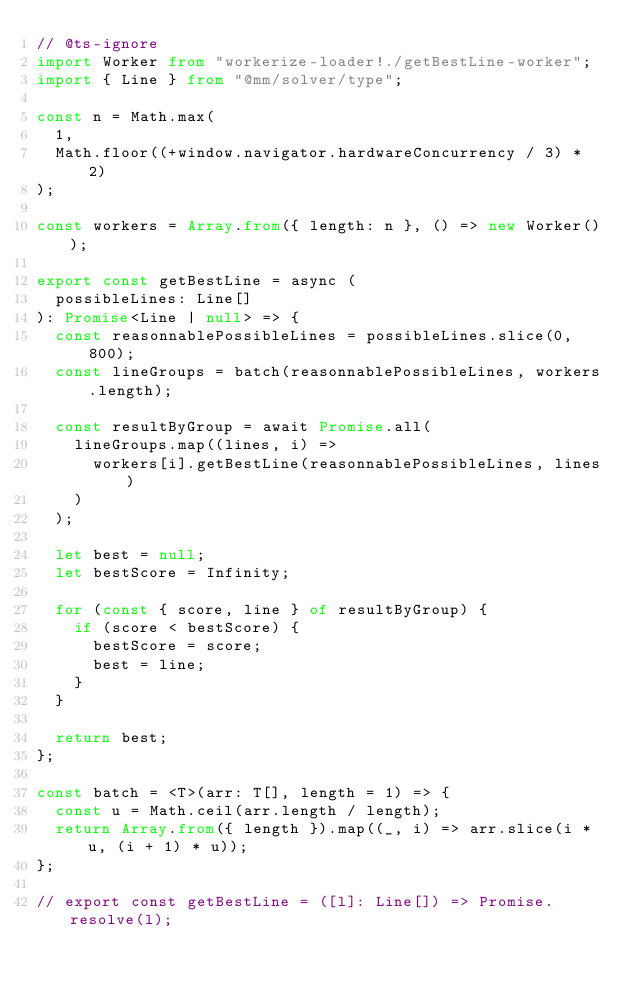<code> <loc_0><loc_0><loc_500><loc_500><_TypeScript_>// @ts-ignore
import Worker from "workerize-loader!./getBestLine-worker";
import { Line } from "@mm/solver/type";

const n = Math.max(
  1,
  Math.floor((+window.navigator.hardwareConcurrency / 3) * 2)
);

const workers = Array.from({ length: n }, () => new Worker());

export const getBestLine = async (
  possibleLines: Line[]
): Promise<Line | null> => {
  const reasonnablePossibleLines = possibleLines.slice(0, 800);
  const lineGroups = batch(reasonnablePossibleLines, workers.length);

  const resultByGroup = await Promise.all(
    lineGroups.map((lines, i) =>
      workers[i].getBestLine(reasonnablePossibleLines, lines)
    )
  );

  let best = null;
  let bestScore = Infinity;

  for (const { score, line } of resultByGroup) {
    if (score < bestScore) {
      bestScore = score;
      best = line;
    }
  }

  return best;
};

const batch = <T>(arr: T[], length = 1) => {
  const u = Math.ceil(arr.length / length);
  return Array.from({ length }).map((_, i) => arr.slice(i * u, (i + 1) * u));
};

// export const getBestLine = ([l]: Line[]) => Promise.resolve(l);
</code> 